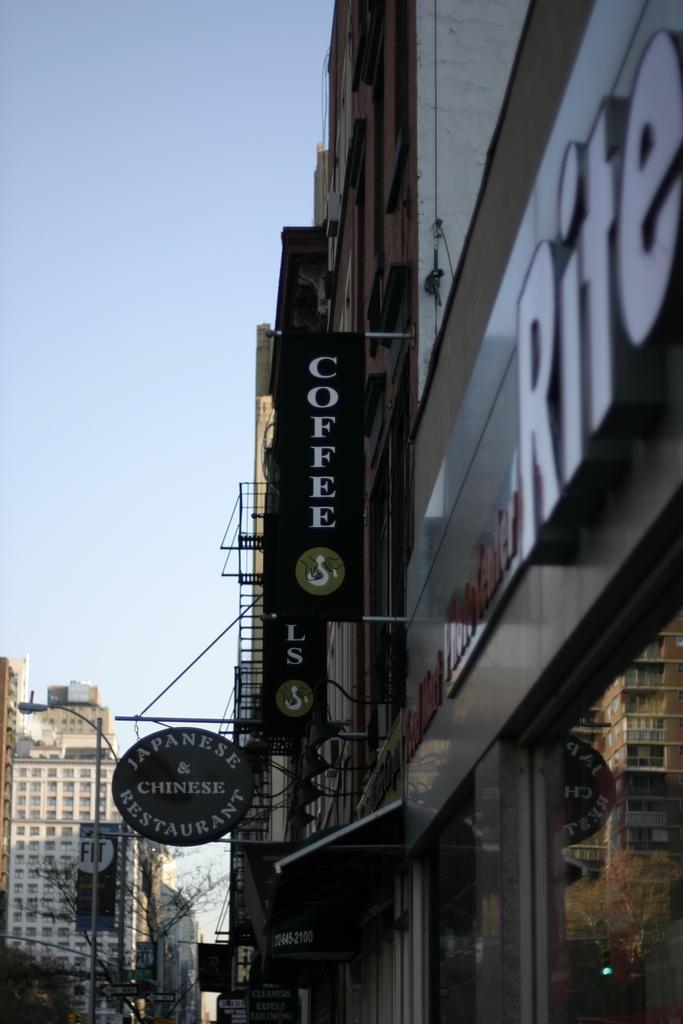How would you summarize this image in a sentence or two? We can see buildings,boards and glass,through this glass we can see building and trees. In the background we can see buildings,light and board on pole,trees and sky. 